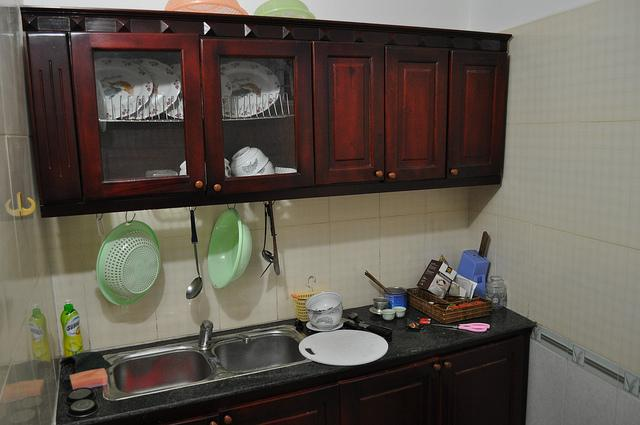What color are the noodle strainers hanging underneath of the cupboard and above the sink? Please explain your reasoning. two. There are two round bowls with many small holes hanging below a cupboard and are light green in color. 